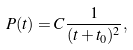<formula> <loc_0><loc_0><loc_500><loc_500>P ( t ) = C \frac { 1 } { ( t + t _ { 0 } ) ^ { 2 } } ,</formula> 